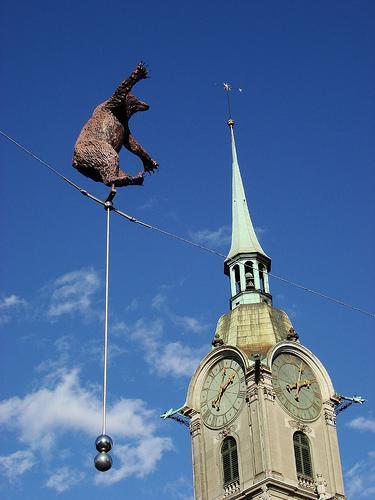How many clocks are show?
Give a very brief answer. 2. How many steeples are shown?
Give a very brief answer. 1. 